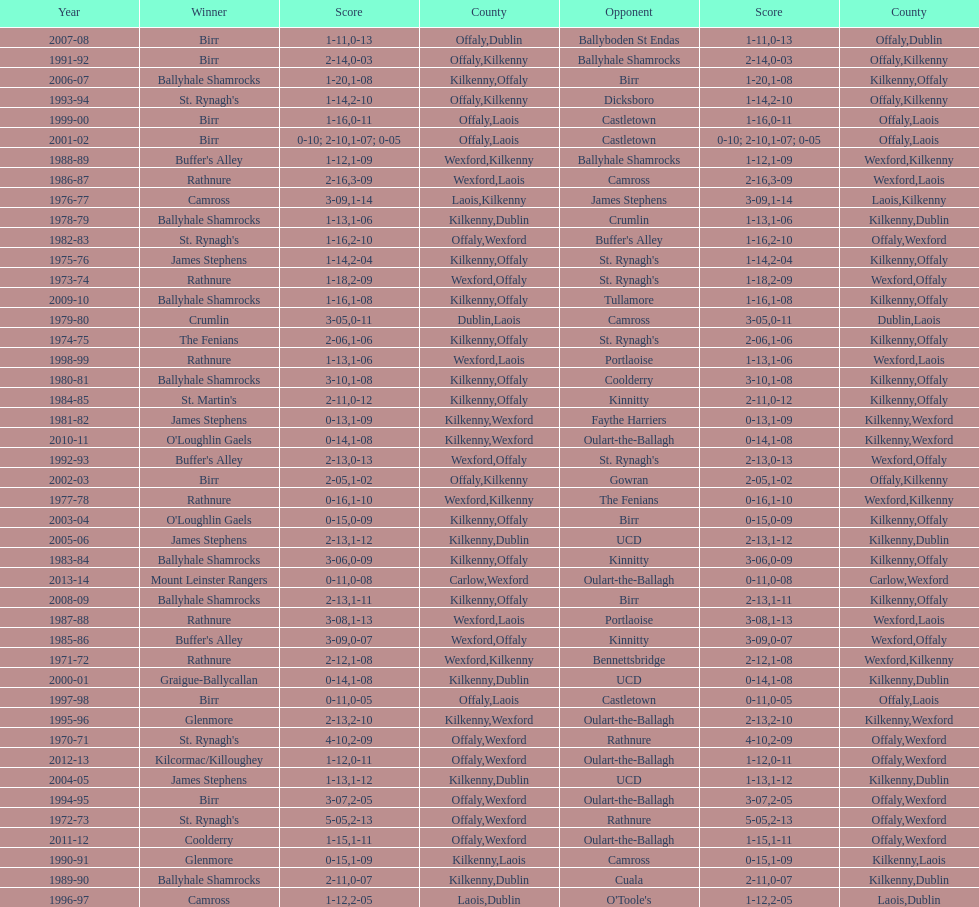Which country had the most wins? Kilkenny. 